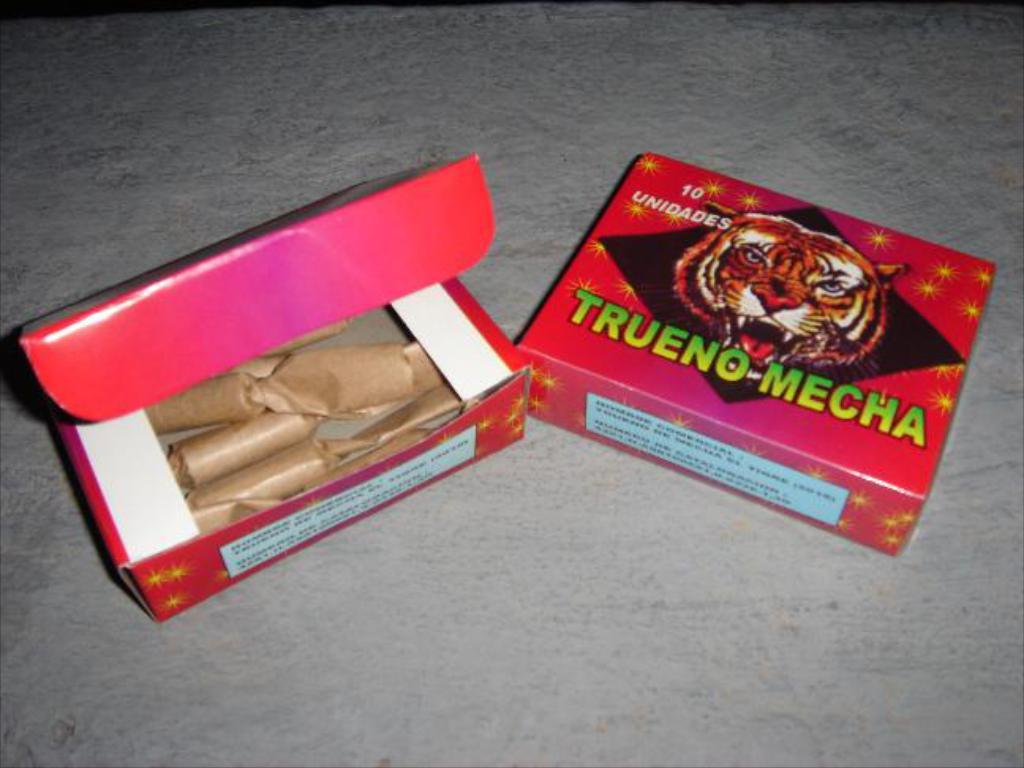<image>
Create a compact narrative representing the image presented. A box of rolled up brown papers and the cover from the brand Trueno-Mecha. 